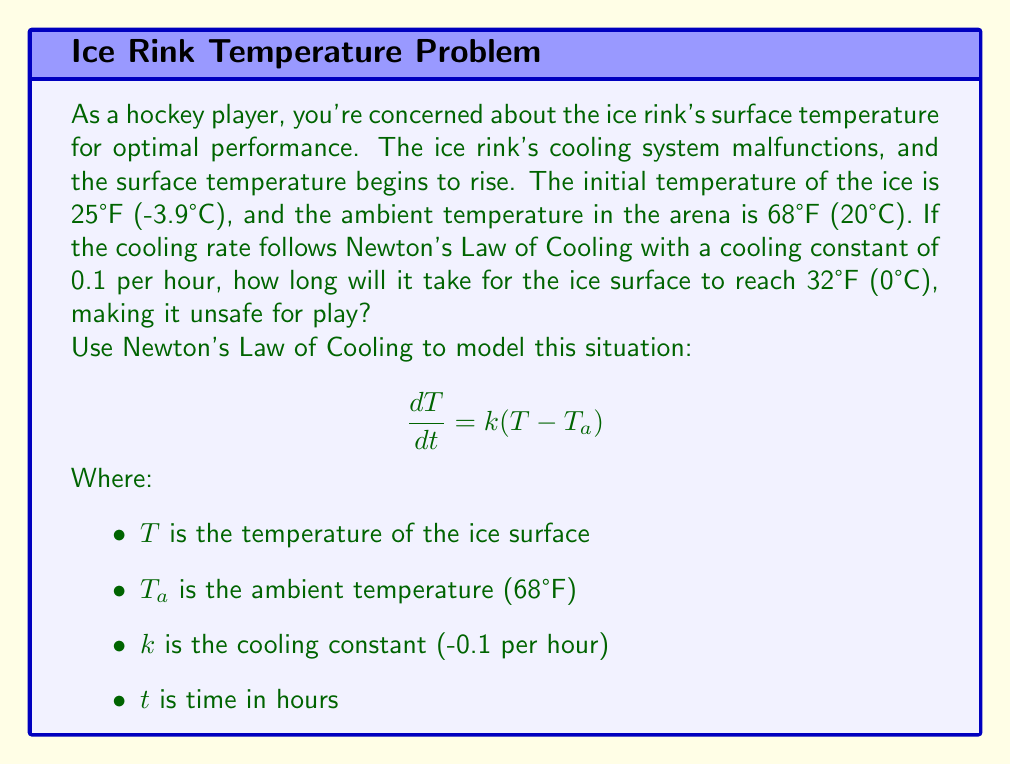Help me with this question. Let's solve this problem step by step using Newton's Law of Cooling:

1) First, we set up the differential equation:

   $$ \frac{dT}{dt} = -0.1(T - 68) $$

2) We can solve this equation by separating variables:

   $$ \frac{dT}{T - 68} = -0.1dt $$

3) Integrating both sides:

   $$ \int \frac{dT}{T - 68} = -0.1 \int dt $$
   $$ \ln|T - 68| = -0.1t + C $$

4) We can find C using the initial condition: T = 25 when t = 0

   $$ \ln|25 - 68| = C $$
   $$ C = \ln(43) $$

5) Substituting back:

   $$ \ln|T - 68| = -0.1t + \ln(43) $$

6) We can simplify this:

   $$ |T - 68| = 43e^{-0.1t} $$

7) Since T < 68, we can remove the absolute value signs:

   $$ T - 68 = -43e^{-0.1t} $$
   $$ T = 68 - 43e^{-0.1t} $$

8) Now, we want to find t when T = 32:

   $$ 32 = 68 - 43e^{-0.1t} $$
   $$ 36 = 43e^{-0.1t} $$
   $$ \ln(\frac{36}{43}) = -0.1t $$
   $$ t = -10\ln(\frac{36}{43}) $$

9) Calculating this value:

   $$ t \approx 1.79 \text{ hours} $$
Answer: It will take approximately 1.79 hours (or about 1 hour and 47 minutes) for the ice surface to reach 32°F (0°C), making it unsafe for play. 